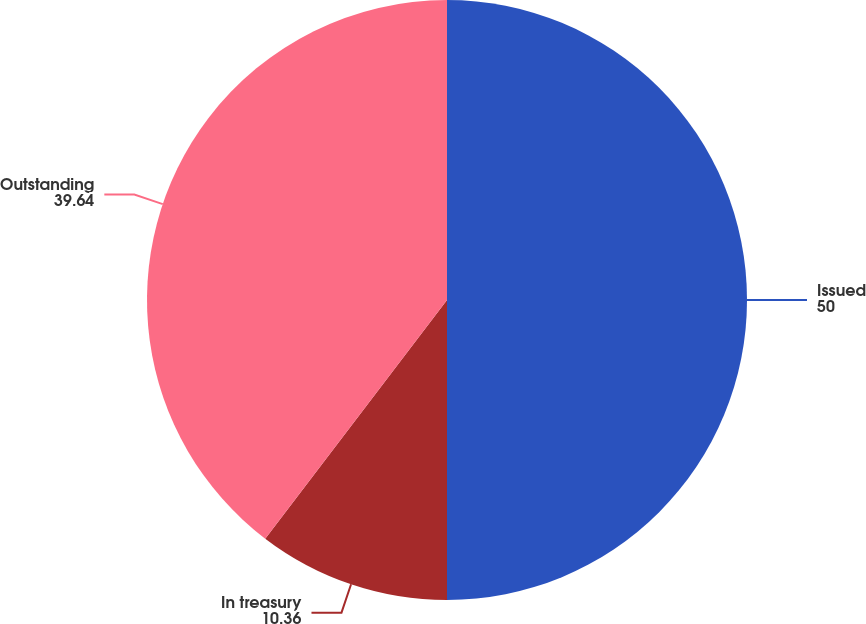Convert chart. <chart><loc_0><loc_0><loc_500><loc_500><pie_chart><fcel>Issued<fcel>In treasury<fcel>Outstanding<nl><fcel>50.0%<fcel>10.36%<fcel>39.64%<nl></chart> 